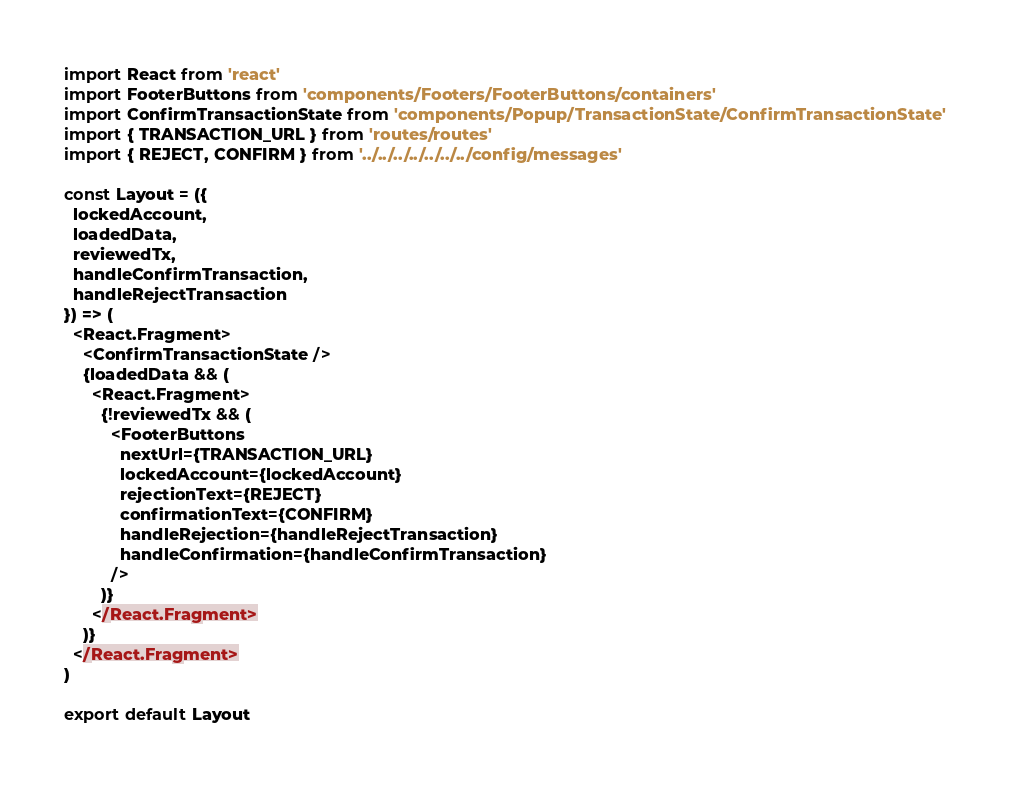<code> <loc_0><loc_0><loc_500><loc_500><_JavaScript_>import React from 'react'
import FooterButtons from 'components/Footers/FooterButtons/containers'
import ConfirmTransactionState from 'components/Popup/TransactionState/ConfirmTransactionState'
import { TRANSACTION_URL } from 'routes/routes'
import { REJECT, CONFIRM } from '../../../../../../../config/messages'

const Layout = ({
  lockedAccount,
  loadedData,
  reviewedTx,
  handleConfirmTransaction,
  handleRejectTransaction
}) => (
  <React.Fragment>
    <ConfirmTransactionState />
    {loadedData && (
      <React.Fragment>
        {!reviewedTx && (
          <FooterButtons
            nextUrl={TRANSACTION_URL}
            lockedAccount={lockedAccount}
            rejectionText={REJECT}
            confirmationText={CONFIRM}
            handleRejection={handleRejectTransaction}
            handleConfirmation={handleConfirmTransaction}
          />
        )}
      </React.Fragment>
    )}
  </React.Fragment>
)

export default Layout
</code> 